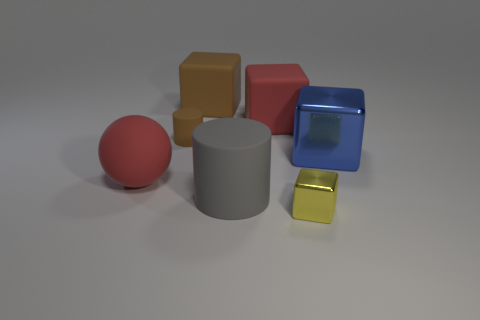What is the big red cube made of?
Your answer should be very brief. Rubber. The big ball that is made of the same material as the big red block is what color?
Provide a short and direct response. Red. Are the sphere and the cube that is in front of the blue cube made of the same material?
Offer a very short reply. No. How many large cylinders have the same material as the big red ball?
Ensure brevity in your answer.  1. What is the shape of the large red object that is on the right side of the brown matte cylinder?
Your answer should be compact. Cube. Is the material of the cylinder to the right of the large brown matte block the same as the small thing that is on the right side of the tiny brown rubber cylinder?
Offer a very short reply. No. Is there a big thing that has the same shape as the small brown thing?
Ensure brevity in your answer.  Yes. What number of objects are red balls behind the gray thing or tiny metal things?
Make the answer very short. 2. Is the number of cubes behind the big blue metal object greater than the number of blue shiny blocks to the left of the small rubber thing?
Your answer should be very brief. Yes. What number of rubber things are blue things or cylinders?
Your answer should be compact. 2. 